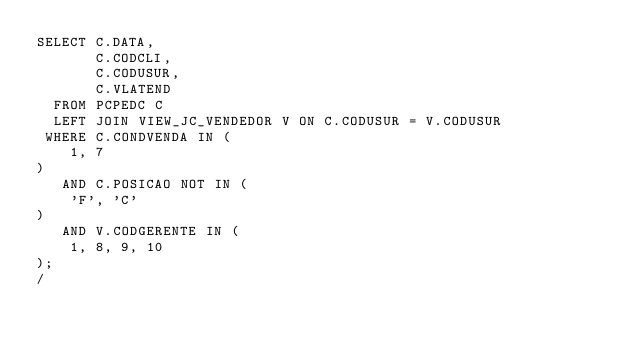<code> <loc_0><loc_0><loc_500><loc_500><_SQL_>SELECT C.DATA,
       C.CODCLI,
       C.CODUSUR,
       C.VLATEND
  FROM PCPEDC C
  LEFT JOIN VIEW_JC_VENDEDOR V ON C.CODUSUR = V.CODUSUR
 WHERE C.CONDVENDA IN (
    1, 7
)
   AND C.POSICAO NOT IN (
    'F', 'C'
)
   AND V.CODGERENTE IN (
    1, 8, 9, 10
);
/</code> 